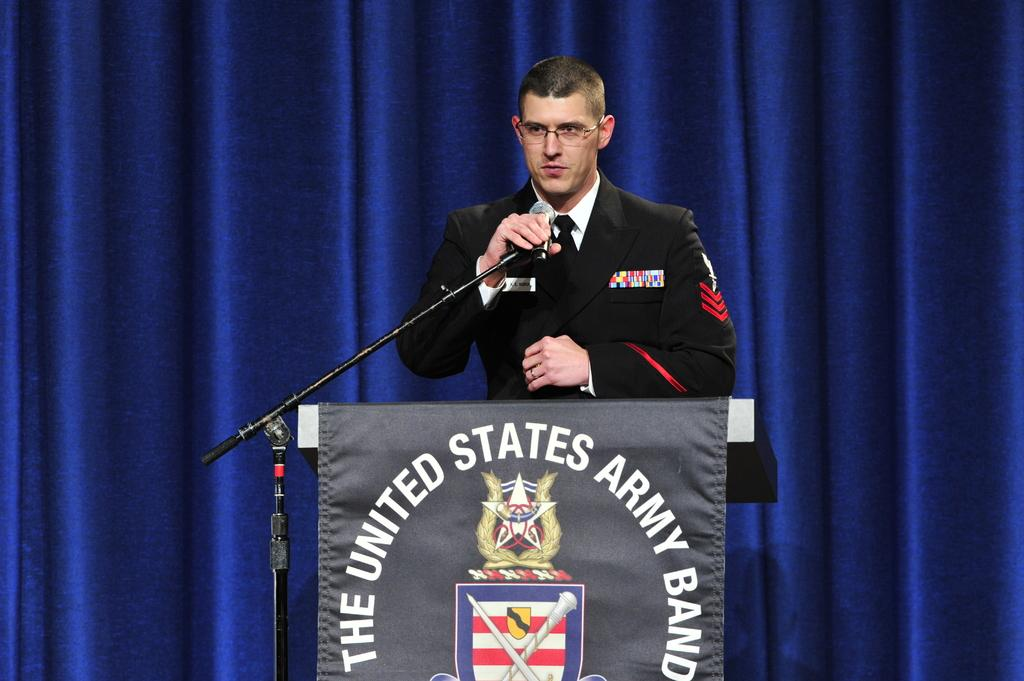<image>
Relay a brief, clear account of the picture shown. a person holding the mic with The United States Army Ban item below them 